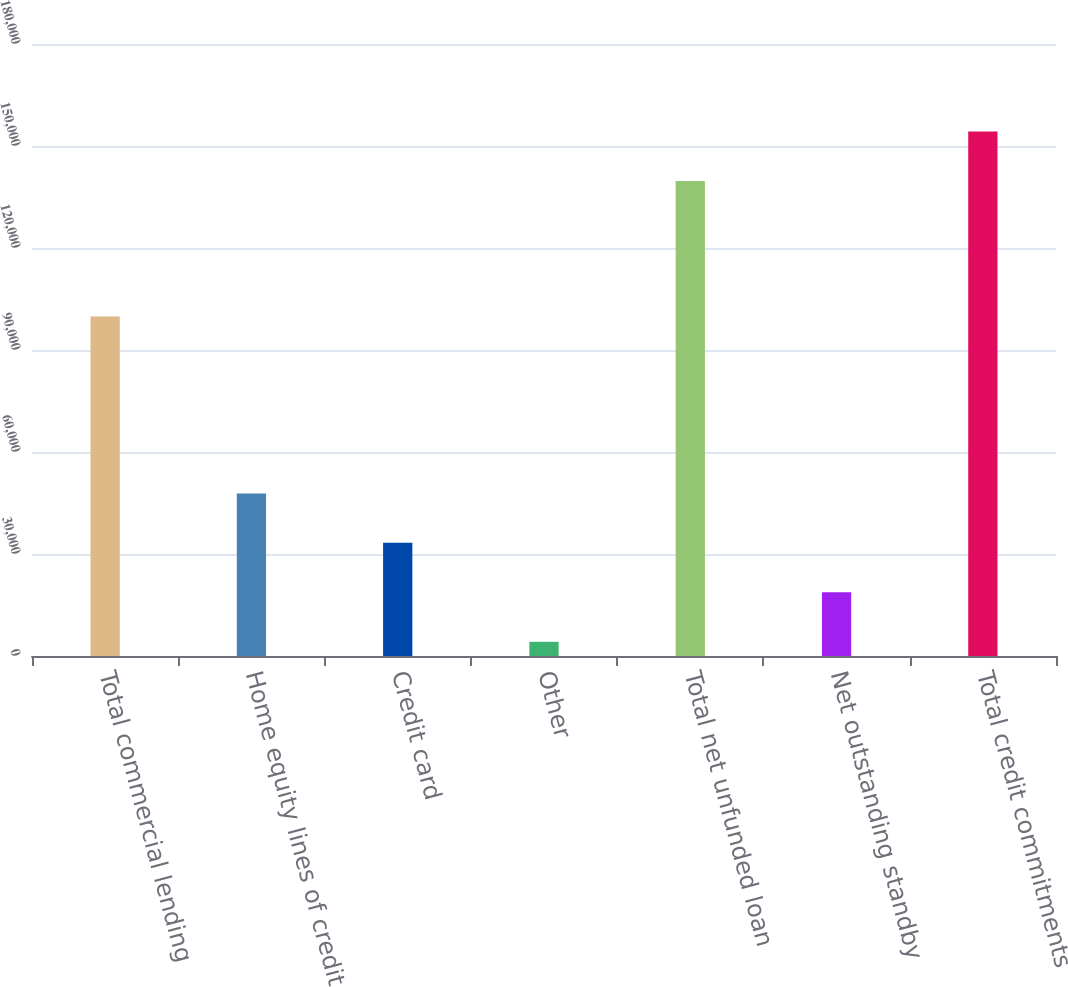Convert chart to OTSL. <chart><loc_0><loc_0><loc_500><loc_500><bar_chart><fcel>Total commercial lending<fcel>Home equity lines of credit<fcel>Credit card<fcel>Other<fcel>Total net unfunded loan<fcel>Net outstanding standby<fcel>Total credit commitments<nl><fcel>99837<fcel>47828<fcel>33278<fcel>4178<fcel>139687<fcel>18728<fcel>154237<nl></chart> 